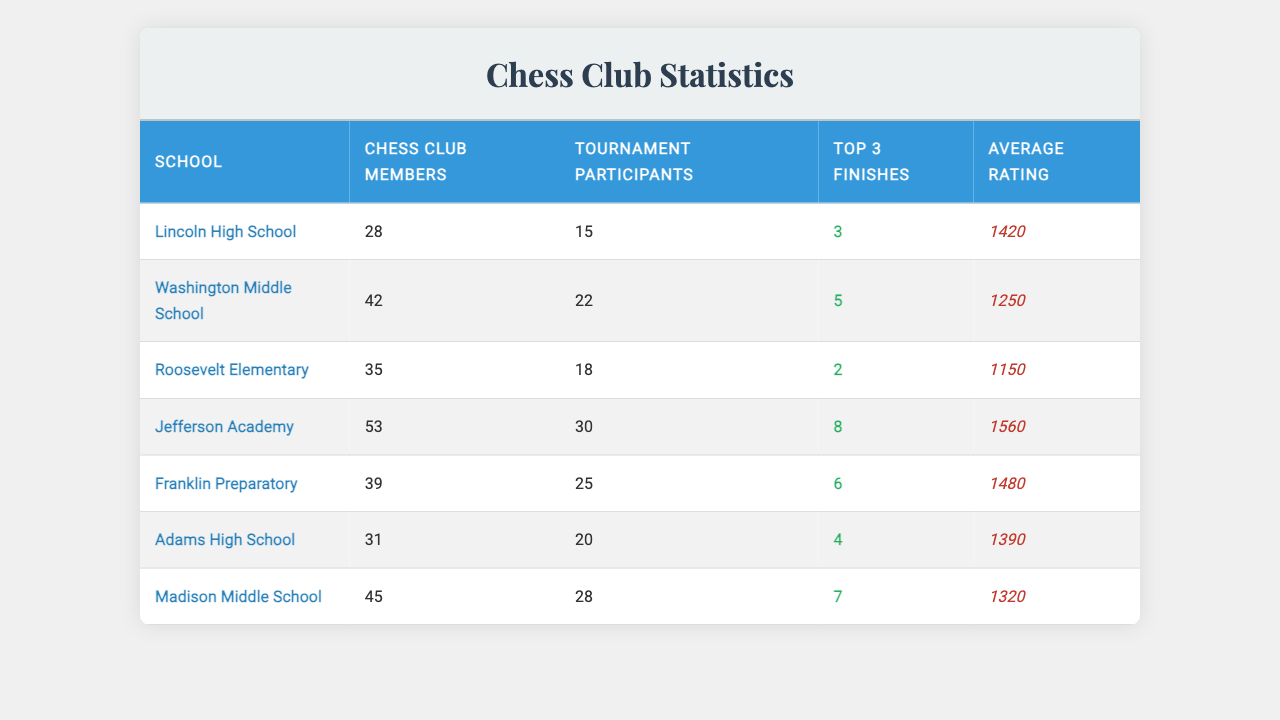What is the school with the highest average rating? To determine which school has the highest average rating, we compare the average ratings listed for each school. Jefferson Academy has an average rating of 1560, which is higher than all other schools.
Answer: Jefferson Academy How many top 3 finishes did Washington Middle School achieve? The table shows that Washington Middle School had 5 top 3 finishes.
Answer: 5 Which school had the most chess club members? We need to find the school with the highest number of chess club members by comparing the values in that column. Jefferson Academy has 53 members, more than any other school.
Answer: Jefferson Academy What is the total number of tournament participants across all schools? We add the number of tournament participants for each school: 15 + 22 + 18 + 30 + 25 + 20 + 28 = 168.
Answer: 168 Is it true that Franklin Preparatory had more top 3 finishes than Roosevelt Elementary? Franklin Preparatory had 6 top 3 finishes while Roosevelt Elementary had 2. Since 6 is greater than 2, the statement is true.
Answer: Yes How does the average rating of Lincoln High School compare to that of Madison Middle School? Lincoln High School has an average rating of 1420, while Madison Middle School has an average rating of 1320. Since 1420 is greater than 1320, Lincoln High School has a higher average rating.
Answer: Lincoln High School has a higher average rating What is the difference in chess club members between Jefferson Academy and Adams High School? Jefferson Academy has 53 chess club members, and Adams High School has 31. The difference is calculated as 53 - 31 = 22.
Answer: 22 Which school has the least tournament participants? We need to look for the smallest value in the tournament participants column. Roosevelt Elementary has 18 participants, which is the least among all schools.
Answer: Roosevelt Elementary What is the average number of top 3 finishes across all schools? We calculate the average by adding all top 3 finishes (3 + 5 + 2 + 8 + 6 + 4 + 7 = 35) and dividing by the number of schools (7): 35 / 7 = 5.
Answer: 5 Did Madison Middle School score better than Franklin Preparatory in terms of average rating? Madison Middle School has an average rating of 1320, while Franklin Preparatory has 1480. Since 1320 is less than 1480, Madison Middle School did not score better.
Answer: No Which school had more tournament participants, Lincoln High School or Adams High School? Lincoln High School had 15 tournament participants, while Adams High School had 20. Therefore, Adams High School had more participants.
Answer: Adams High School 